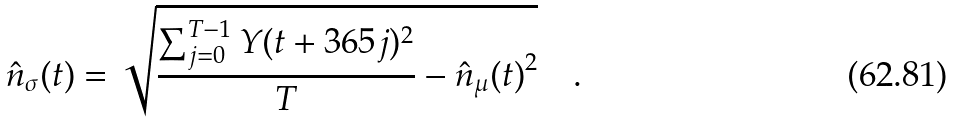<formula> <loc_0><loc_0><loc_500><loc_500>\hat { n } _ { \sigma } ( t ) = \sqrt { \frac { \sum _ { j = 0 } ^ { T - 1 } Y ( t + 3 6 5 j ) ^ { 2 } } { T } - { \hat { n } _ { \mu } ( t ) } ^ { 2 } } \quad .</formula> 